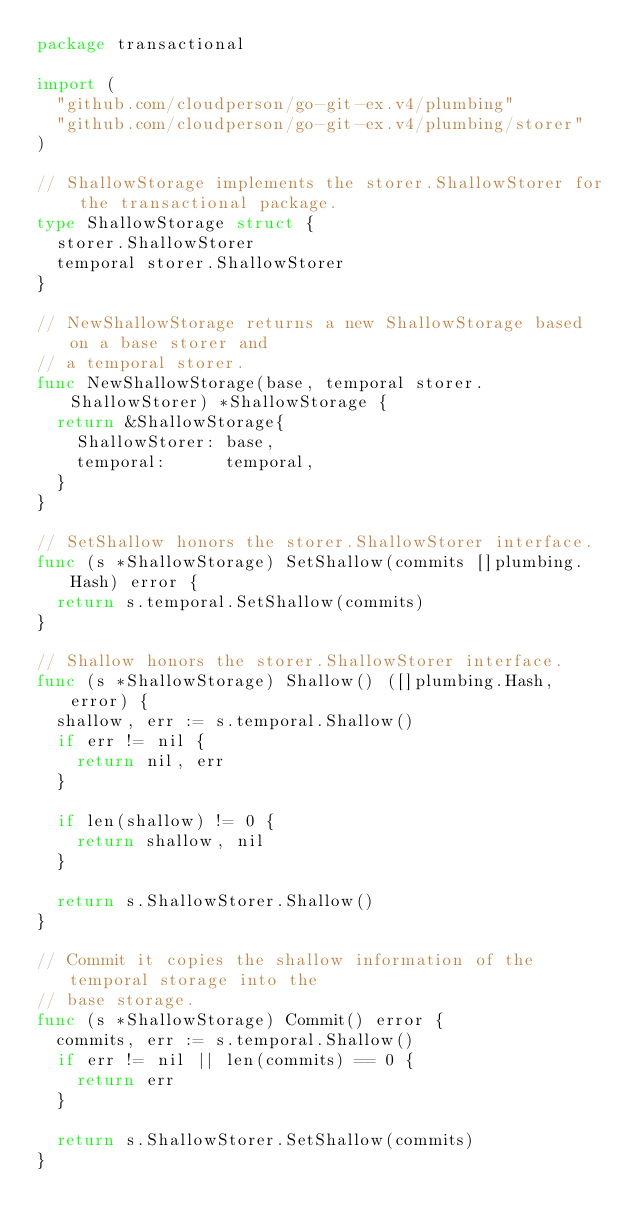Convert code to text. <code><loc_0><loc_0><loc_500><loc_500><_Go_>package transactional

import (
	"github.com/cloudperson/go-git-ex.v4/plumbing"
	"github.com/cloudperson/go-git-ex.v4/plumbing/storer"
)

// ShallowStorage implements the storer.ShallowStorer for the transactional package.
type ShallowStorage struct {
	storer.ShallowStorer
	temporal storer.ShallowStorer
}

// NewShallowStorage returns a new ShallowStorage based on a base storer and
// a temporal storer.
func NewShallowStorage(base, temporal storer.ShallowStorer) *ShallowStorage {
	return &ShallowStorage{
		ShallowStorer: base,
		temporal:      temporal,
	}
}

// SetShallow honors the storer.ShallowStorer interface.
func (s *ShallowStorage) SetShallow(commits []plumbing.Hash) error {
	return s.temporal.SetShallow(commits)
}

// Shallow honors the storer.ShallowStorer interface.
func (s *ShallowStorage) Shallow() ([]plumbing.Hash, error) {
	shallow, err := s.temporal.Shallow()
	if err != nil {
		return nil, err
	}

	if len(shallow) != 0 {
		return shallow, nil
	}

	return s.ShallowStorer.Shallow()
}

// Commit it copies the shallow information of the temporal storage into the
// base storage.
func (s *ShallowStorage) Commit() error {
	commits, err := s.temporal.Shallow()
	if err != nil || len(commits) == 0 {
		return err
	}

	return s.ShallowStorer.SetShallow(commits)
}
</code> 